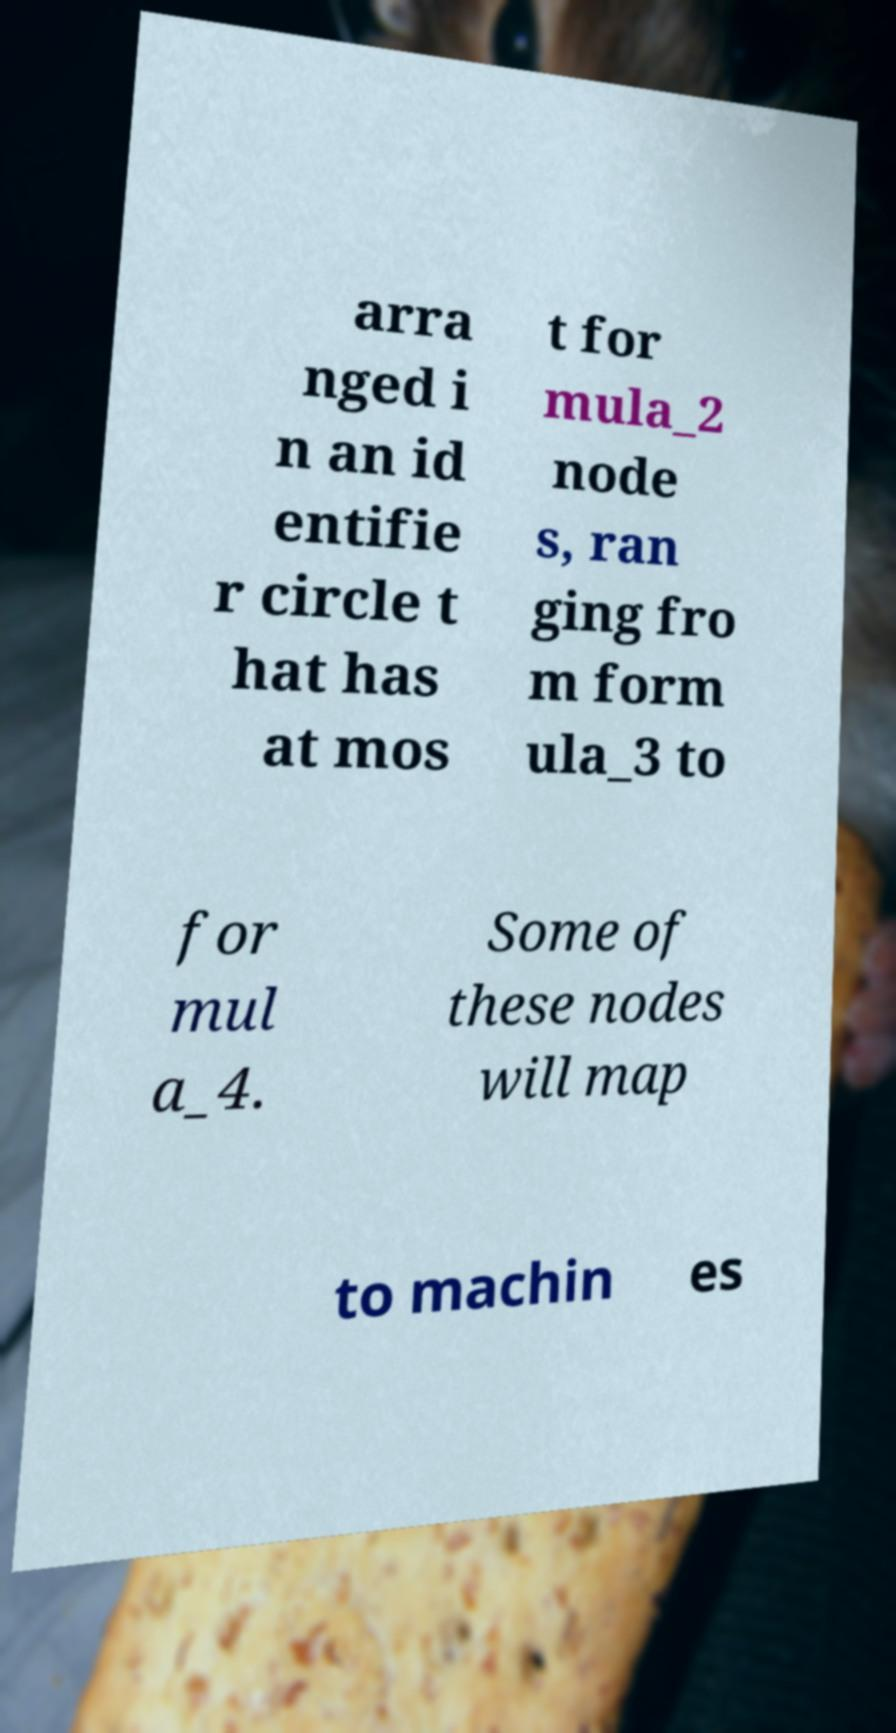For documentation purposes, I need the text within this image transcribed. Could you provide that? arra nged i n an id entifie r circle t hat has at mos t for mula_2 node s, ran ging fro m form ula_3 to for mul a_4. Some of these nodes will map to machin es 